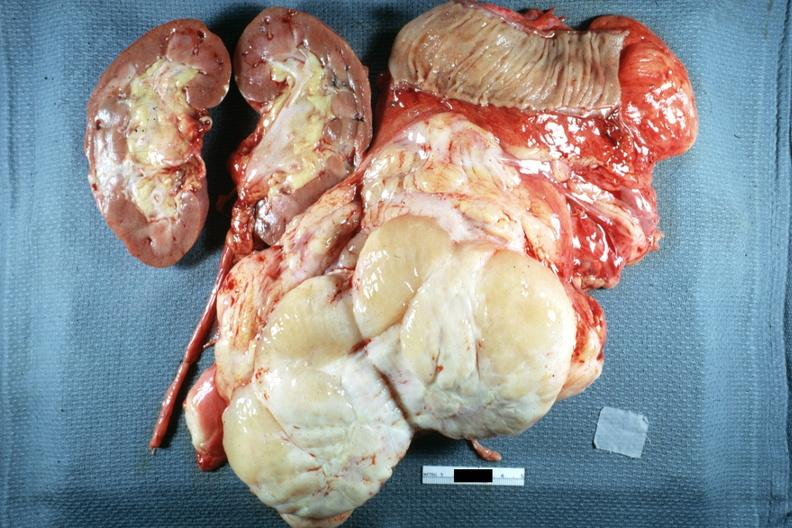how does this image show whole tumor?
Answer the question using a single word or phrase. With kidney and portion of jejunum resected surgically cut surface shows typical fish flesh and yellow sarcoma 